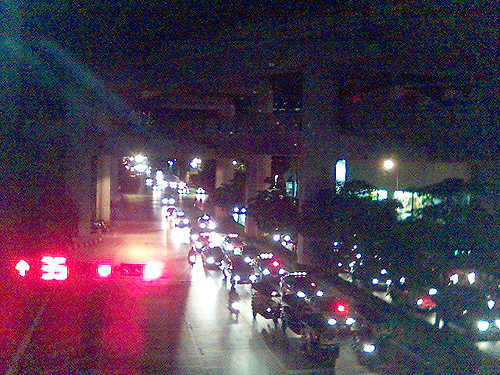<image>What city is this? I am not sure which city it is. It could be either Chicago, Boston, New York, London, Asian, Los Angeles. What city is this? I am not sure what city this is. It can be either Chicago, Boston, New York, London, or Los Angeles. 